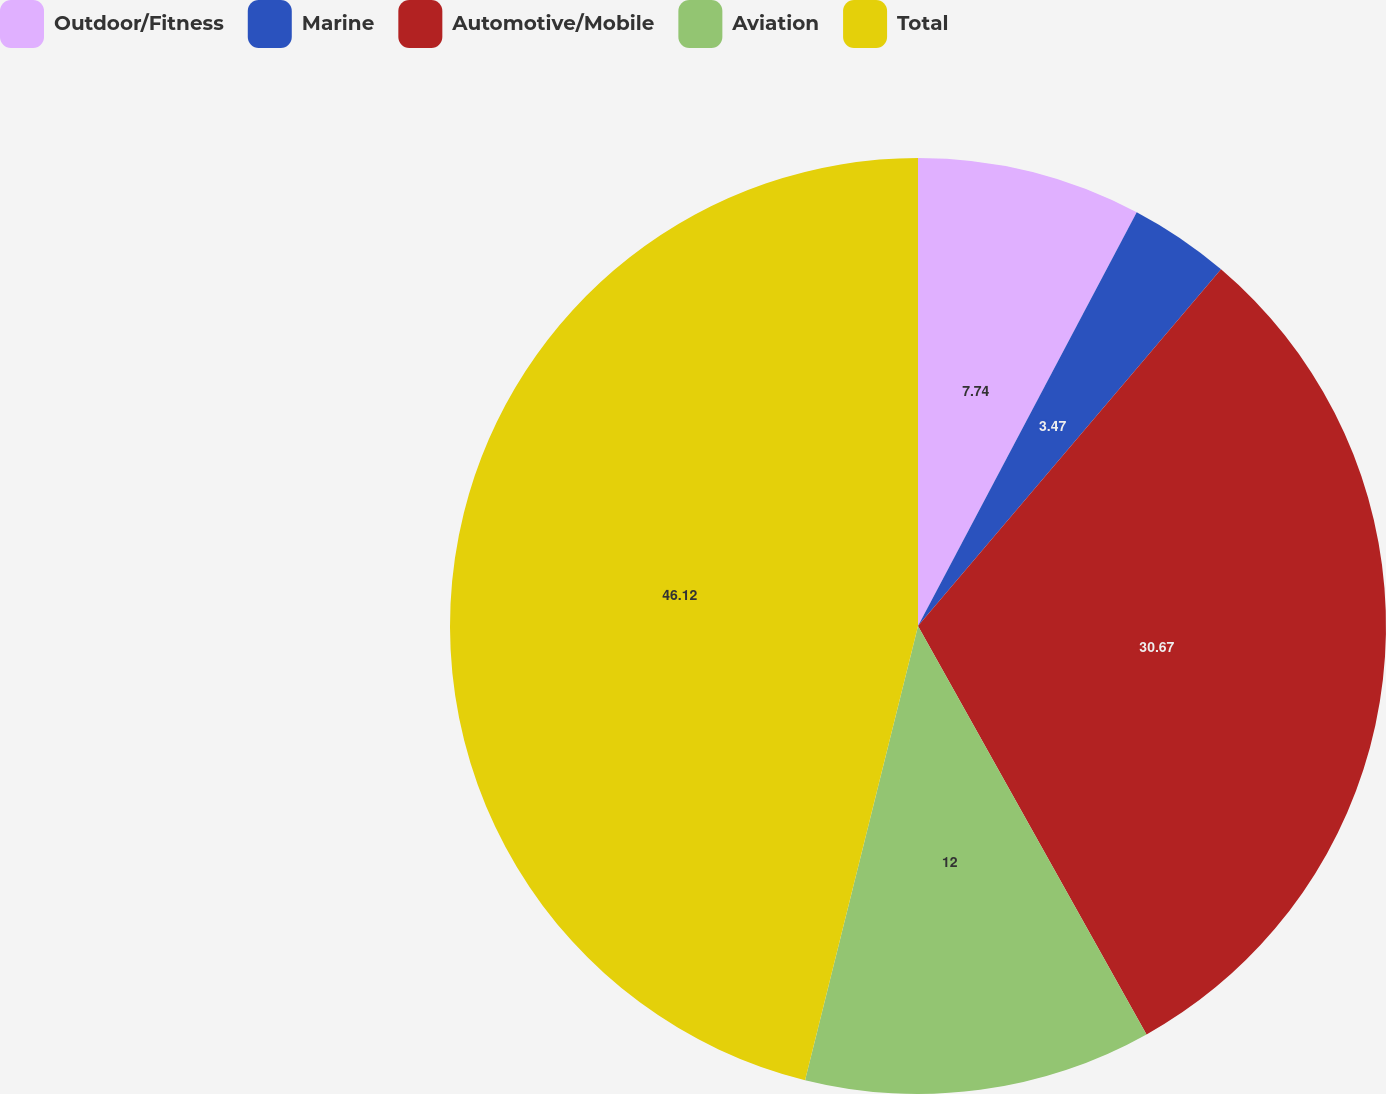Convert chart to OTSL. <chart><loc_0><loc_0><loc_500><loc_500><pie_chart><fcel>Outdoor/Fitness<fcel>Marine<fcel>Automotive/Mobile<fcel>Aviation<fcel>Total<nl><fcel>7.74%<fcel>3.47%<fcel>30.67%<fcel>12.0%<fcel>46.12%<nl></chart> 